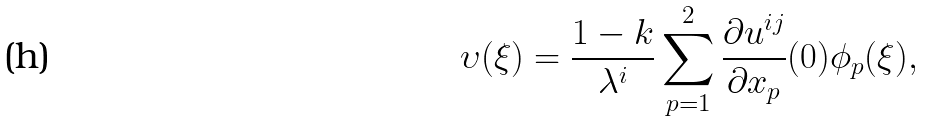Convert formula to latex. <formula><loc_0><loc_0><loc_500><loc_500>\upsilon ( \xi ) = \frac { 1 - k } { \lambda ^ { i } } \sum _ { p = 1 } ^ { 2 } \frac { \partial u ^ { i j } } { \partial x _ { p } } ( 0 ) \phi _ { p } ( \xi ) ,</formula> 